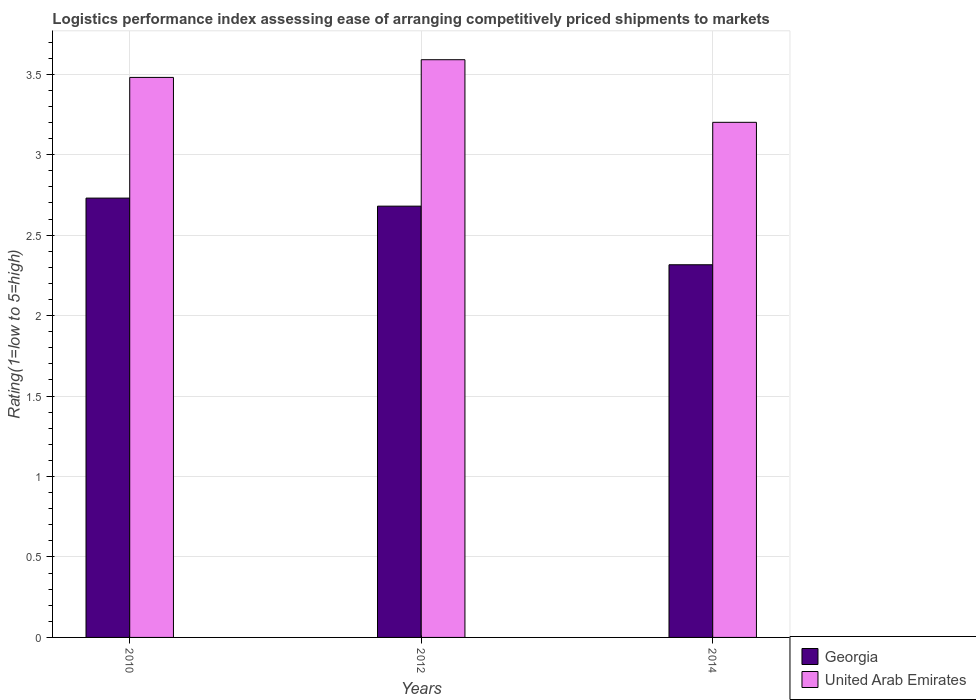How many different coloured bars are there?
Offer a terse response. 2. How many groups of bars are there?
Your response must be concise. 3. Are the number of bars per tick equal to the number of legend labels?
Your answer should be compact. Yes. Are the number of bars on each tick of the X-axis equal?
Make the answer very short. Yes. How many bars are there on the 1st tick from the left?
Make the answer very short. 2. What is the label of the 2nd group of bars from the left?
Provide a succinct answer. 2012. What is the Logistic performance index in United Arab Emirates in 2012?
Give a very brief answer. 3.59. Across all years, what is the maximum Logistic performance index in United Arab Emirates?
Provide a succinct answer. 3.59. Across all years, what is the minimum Logistic performance index in United Arab Emirates?
Give a very brief answer. 3.2. In which year was the Logistic performance index in United Arab Emirates maximum?
Ensure brevity in your answer.  2012. In which year was the Logistic performance index in United Arab Emirates minimum?
Provide a succinct answer. 2014. What is the total Logistic performance index in Georgia in the graph?
Offer a very short reply. 7.73. What is the difference between the Logistic performance index in United Arab Emirates in 2012 and that in 2014?
Provide a short and direct response. 0.39. What is the difference between the Logistic performance index in United Arab Emirates in 2014 and the Logistic performance index in Georgia in 2012?
Offer a terse response. 0.52. What is the average Logistic performance index in United Arab Emirates per year?
Provide a succinct answer. 3.42. In the year 2012, what is the difference between the Logistic performance index in Georgia and Logistic performance index in United Arab Emirates?
Make the answer very short. -0.91. What is the ratio of the Logistic performance index in United Arab Emirates in 2010 to that in 2012?
Your response must be concise. 0.97. Is the Logistic performance index in United Arab Emirates in 2012 less than that in 2014?
Offer a very short reply. No. Is the difference between the Logistic performance index in Georgia in 2012 and 2014 greater than the difference between the Logistic performance index in United Arab Emirates in 2012 and 2014?
Offer a very short reply. No. What is the difference between the highest and the second highest Logistic performance index in Georgia?
Your answer should be very brief. 0.05. What is the difference between the highest and the lowest Logistic performance index in Georgia?
Offer a very short reply. 0.41. Is the sum of the Logistic performance index in Georgia in 2012 and 2014 greater than the maximum Logistic performance index in United Arab Emirates across all years?
Offer a terse response. Yes. What does the 2nd bar from the left in 2012 represents?
Ensure brevity in your answer.  United Arab Emirates. What does the 1st bar from the right in 2012 represents?
Ensure brevity in your answer.  United Arab Emirates. How many bars are there?
Your answer should be compact. 6. Are the values on the major ticks of Y-axis written in scientific E-notation?
Your response must be concise. No. How are the legend labels stacked?
Offer a terse response. Vertical. What is the title of the graph?
Offer a terse response. Logistics performance index assessing ease of arranging competitively priced shipments to markets. What is the label or title of the Y-axis?
Provide a succinct answer. Rating(1=low to 5=high). What is the Rating(1=low to 5=high) of Georgia in 2010?
Offer a terse response. 2.73. What is the Rating(1=low to 5=high) in United Arab Emirates in 2010?
Ensure brevity in your answer.  3.48. What is the Rating(1=low to 5=high) in Georgia in 2012?
Give a very brief answer. 2.68. What is the Rating(1=low to 5=high) in United Arab Emirates in 2012?
Your answer should be compact. 3.59. What is the Rating(1=low to 5=high) of Georgia in 2014?
Offer a terse response. 2.32. What is the Rating(1=low to 5=high) of United Arab Emirates in 2014?
Give a very brief answer. 3.2. Across all years, what is the maximum Rating(1=low to 5=high) of Georgia?
Your response must be concise. 2.73. Across all years, what is the maximum Rating(1=low to 5=high) of United Arab Emirates?
Provide a succinct answer. 3.59. Across all years, what is the minimum Rating(1=low to 5=high) in Georgia?
Your response must be concise. 2.32. Across all years, what is the minimum Rating(1=low to 5=high) of United Arab Emirates?
Your answer should be very brief. 3.2. What is the total Rating(1=low to 5=high) of Georgia in the graph?
Offer a very short reply. 7.73. What is the total Rating(1=low to 5=high) in United Arab Emirates in the graph?
Provide a succinct answer. 10.27. What is the difference between the Rating(1=low to 5=high) of United Arab Emirates in 2010 and that in 2012?
Offer a terse response. -0.11. What is the difference between the Rating(1=low to 5=high) in Georgia in 2010 and that in 2014?
Give a very brief answer. 0.41. What is the difference between the Rating(1=low to 5=high) of United Arab Emirates in 2010 and that in 2014?
Your answer should be compact. 0.28. What is the difference between the Rating(1=low to 5=high) of Georgia in 2012 and that in 2014?
Offer a very short reply. 0.36. What is the difference between the Rating(1=low to 5=high) in United Arab Emirates in 2012 and that in 2014?
Provide a short and direct response. 0.39. What is the difference between the Rating(1=low to 5=high) in Georgia in 2010 and the Rating(1=low to 5=high) in United Arab Emirates in 2012?
Make the answer very short. -0.86. What is the difference between the Rating(1=low to 5=high) of Georgia in 2010 and the Rating(1=low to 5=high) of United Arab Emirates in 2014?
Your response must be concise. -0.47. What is the difference between the Rating(1=low to 5=high) of Georgia in 2012 and the Rating(1=low to 5=high) of United Arab Emirates in 2014?
Offer a very short reply. -0.52. What is the average Rating(1=low to 5=high) in Georgia per year?
Your response must be concise. 2.58. What is the average Rating(1=low to 5=high) of United Arab Emirates per year?
Your answer should be very brief. 3.42. In the year 2010, what is the difference between the Rating(1=low to 5=high) in Georgia and Rating(1=low to 5=high) in United Arab Emirates?
Give a very brief answer. -0.75. In the year 2012, what is the difference between the Rating(1=low to 5=high) of Georgia and Rating(1=low to 5=high) of United Arab Emirates?
Give a very brief answer. -0.91. In the year 2014, what is the difference between the Rating(1=low to 5=high) in Georgia and Rating(1=low to 5=high) in United Arab Emirates?
Your response must be concise. -0.89. What is the ratio of the Rating(1=low to 5=high) of Georgia in 2010 to that in 2012?
Your answer should be compact. 1.02. What is the ratio of the Rating(1=low to 5=high) in United Arab Emirates in 2010 to that in 2012?
Make the answer very short. 0.97. What is the ratio of the Rating(1=low to 5=high) in Georgia in 2010 to that in 2014?
Ensure brevity in your answer.  1.18. What is the ratio of the Rating(1=low to 5=high) in United Arab Emirates in 2010 to that in 2014?
Provide a succinct answer. 1.09. What is the ratio of the Rating(1=low to 5=high) in Georgia in 2012 to that in 2014?
Your answer should be compact. 1.16. What is the ratio of the Rating(1=low to 5=high) in United Arab Emirates in 2012 to that in 2014?
Make the answer very short. 1.12. What is the difference between the highest and the second highest Rating(1=low to 5=high) of United Arab Emirates?
Your answer should be very brief. 0.11. What is the difference between the highest and the lowest Rating(1=low to 5=high) of Georgia?
Your answer should be compact. 0.41. What is the difference between the highest and the lowest Rating(1=low to 5=high) of United Arab Emirates?
Offer a very short reply. 0.39. 